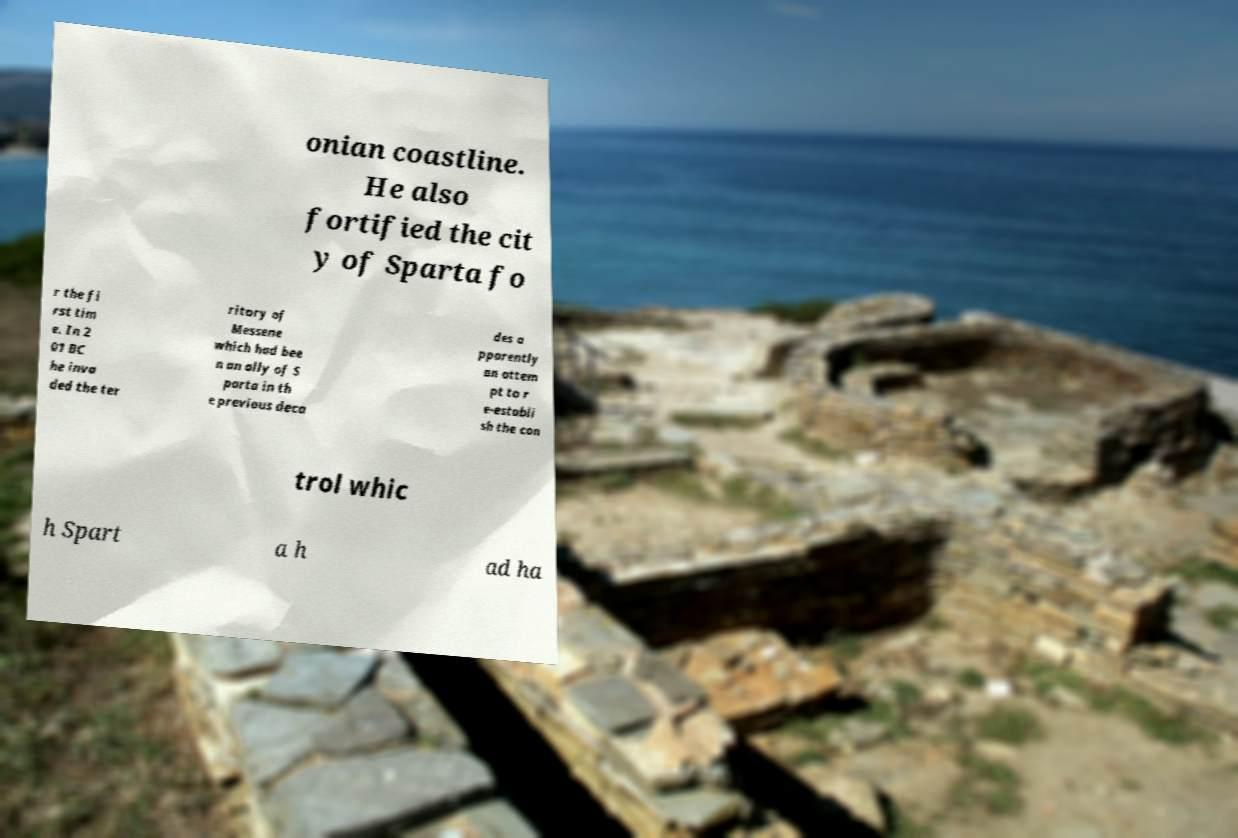Can you read and provide the text displayed in the image?This photo seems to have some interesting text. Can you extract and type it out for me? onian coastline. He also fortified the cit y of Sparta fo r the fi rst tim e. In 2 01 BC he inva ded the ter ritory of Messene which had bee n an ally of S parta in th e previous deca des a pparently an attem pt to r e-establi sh the con trol whic h Spart a h ad ha 